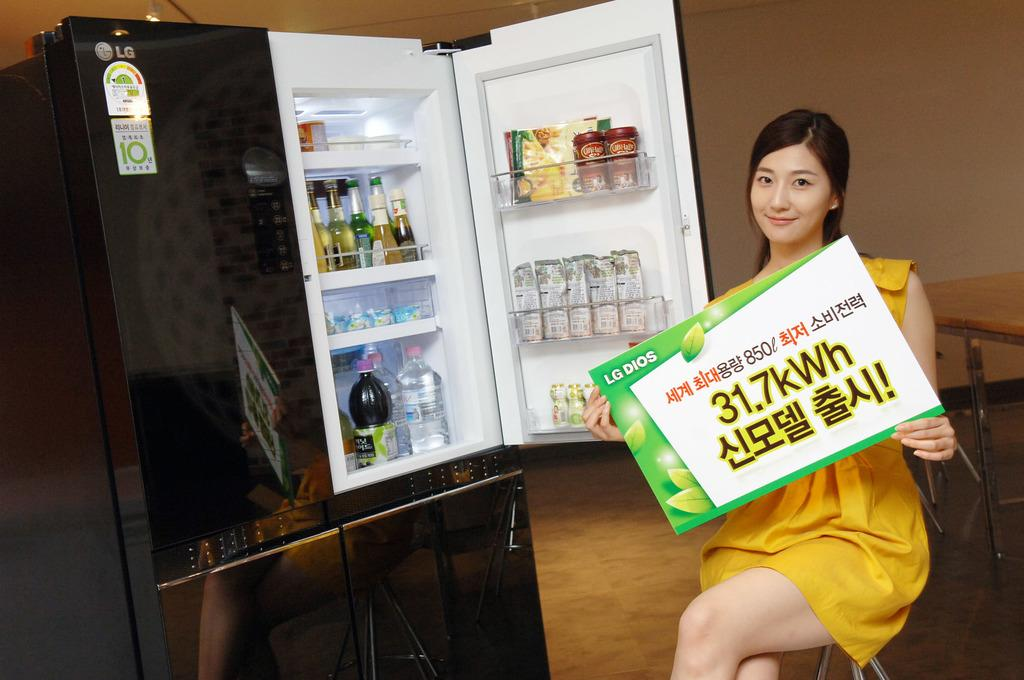<image>
Offer a succinct explanation of the picture presented. a woman in front of a mini fridge with a sign saying 31.7kWh 